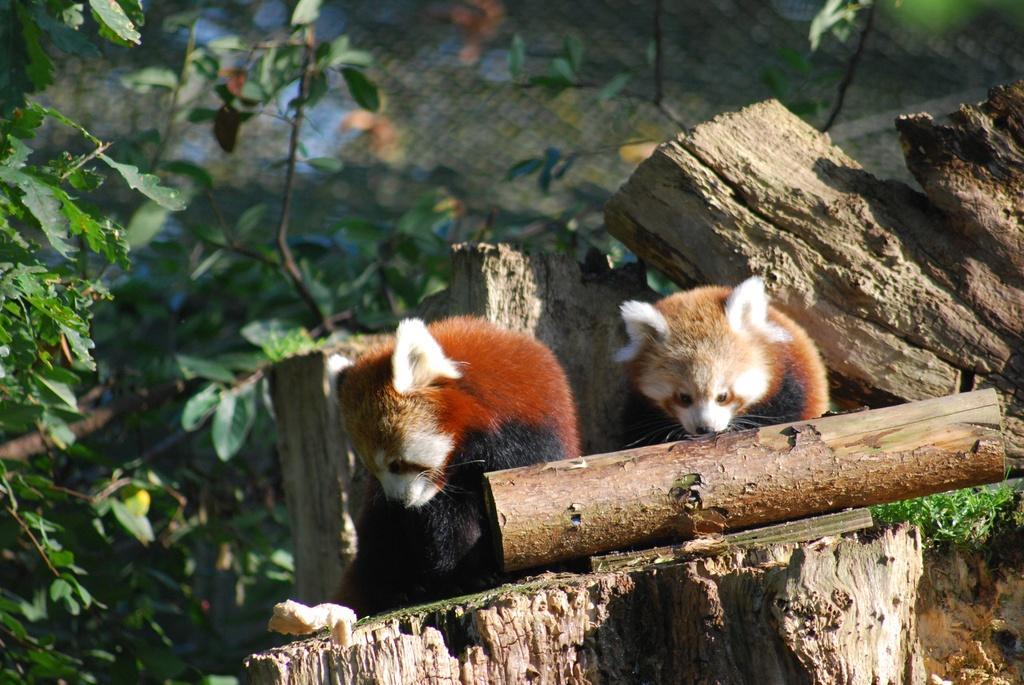In one or two sentences, can you explain what this image depicts? In this image we can see red pandas on the log. We can also see some grass, plants and a fence. 